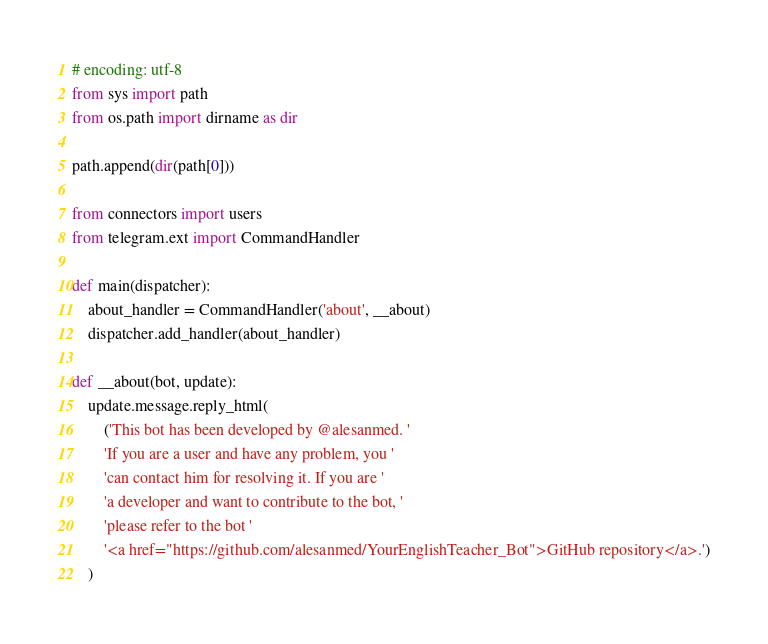Convert code to text. <code><loc_0><loc_0><loc_500><loc_500><_Python_># encoding: utf-8
from sys import path
from os.path import dirname as dir

path.append(dir(path[0]))

from connectors import users
from telegram.ext import CommandHandler

def main(dispatcher):
    about_handler = CommandHandler('about', __about)
    dispatcher.add_handler(about_handler)
    
def __about(bot, update):
    update.message.reply_html(
        ('This bot has been developed by @alesanmed. '
        'If you are a user and have any problem, you '
        'can contact him for resolving it. If you are '
        'a developer and want to contribute to the bot, '
        'please refer to the bot '
        '<a href="https://github.com/alesanmed/YourEnglishTeacher_Bot">GitHub repository</a>.')
    )</code> 